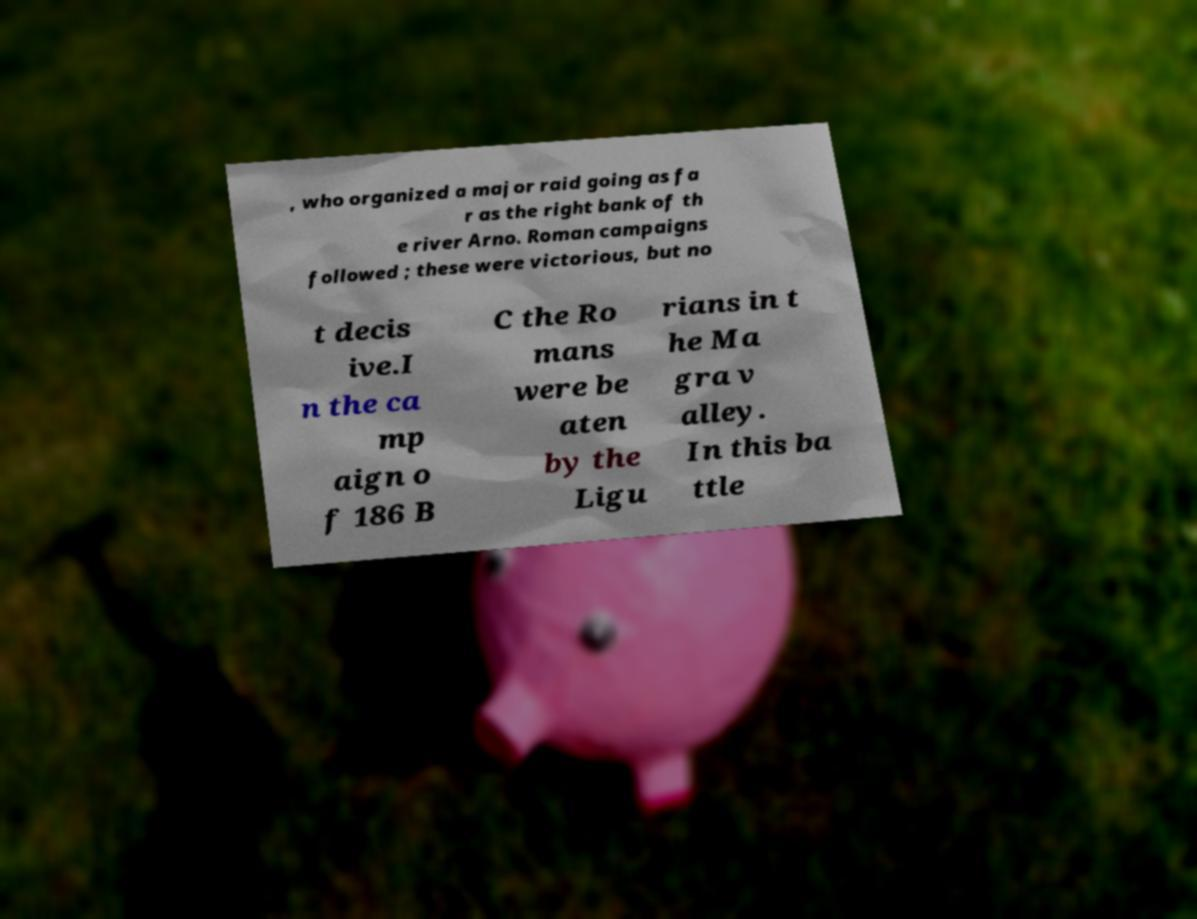Please identify and transcribe the text found in this image. , who organized a major raid going as fa r as the right bank of th e river Arno. Roman campaigns followed ; these were victorious, but no t decis ive.I n the ca mp aign o f 186 B C the Ro mans were be aten by the Ligu rians in t he Ma gra v alley. In this ba ttle 